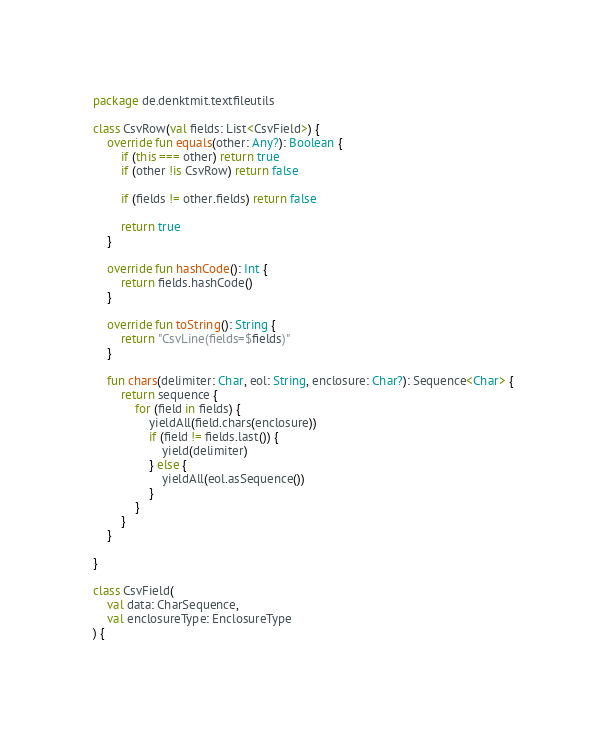<code> <loc_0><loc_0><loc_500><loc_500><_Kotlin_>package de.denktmit.textfileutils

class CsvRow(val fields: List<CsvField>) {
    override fun equals(other: Any?): Boolean {
        if (this === other) return true
        if (other !is CsvRow) return false

        if (fields != other.fields) return false

        return true
    }

    override fun hashCode(): Int {
        return fields.hashCode()
    }

    override fun toString(): String {
        return "CsvLine(fields=$fields)"
    }

    fun chars(delimiter: Char, eol: String, enclosure: Char?): Sequence<Char> {
        return sequence {
            for (field in fields) {
                yieldAll(field.chars(enclosure))
                if (field != fields.last()) {
                    yield(delimiter)
                } else {
                    yieldAll(eol.asSequence())
                }
            }
        }
    }

}

class CsvField(
    val data: CharSequence,
    val enclosureType: EnclosureType
) {</code> 